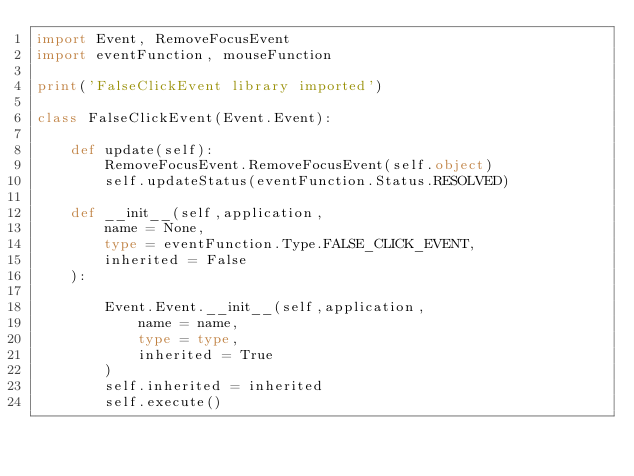<code> <loc_0><loc_0><loc_500><loc_500><_Python_>import Event, RemoveFocusEvent
import eventFunction, mouseFunction

print('FalseClickEvent library imported')

class FalseClickEvent(Event.Event):

    def update(self):
        RemoveFocusEvent.RemoveFocusEvent(self.object)
        self.updateStatus(eventFunction.Status.RESOLVED)

    def __init__(self,application,
        name = None,
        type = eventFunction.Type.FALSE_CLICK_EVENT,
        inherited = False
    ):

        Event.Event.__init__(self,application,
            name = name,
            type = type,
            inherited = True
        )
        self.inherited = inherited
        self.execute()
</code> 